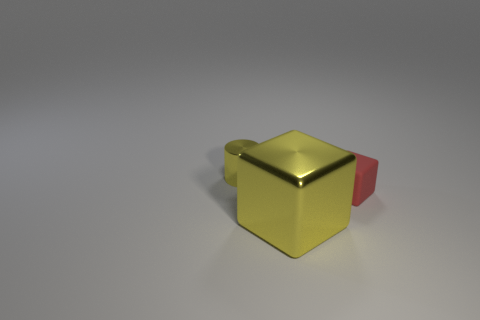Is there any other thing that is the same size as the metallic block?
Your answer should be compact. No. There is a yellow metal object that is behind the tiny matte thing; what is its shape?
Provide a short and direct response. Cylinder. The other object that is the same color as the big metal object is what size?
Provide a short and direct response. Small. Are there any metal cylinders of the same size as the red rubber object?
Keep it short and to the point. Yes. Are the small object right of the yellow metallic cylinder and the tiny yellow cylinder made of the same material?
Provide a succinct answer. No. Is the number of big metallic objects that are in front of the small yellow object the same as the number of big metal cubes in front of the yellow cube?
Give a very brief answer. No. What is the shape of the thing that is on the left side of the red matte block and behind the big yellow metallic cube?
Provide a short and direct response. Cylinder. How many red rubber objects are behind the large yellow block?
Your answer should be very brief. 1. How many other things are there of the same shape as the red rubber thing?
Keep it short and to the point. 1. Are there fewer red blocks than big red metallic objects?
Your response must be concise. No. 